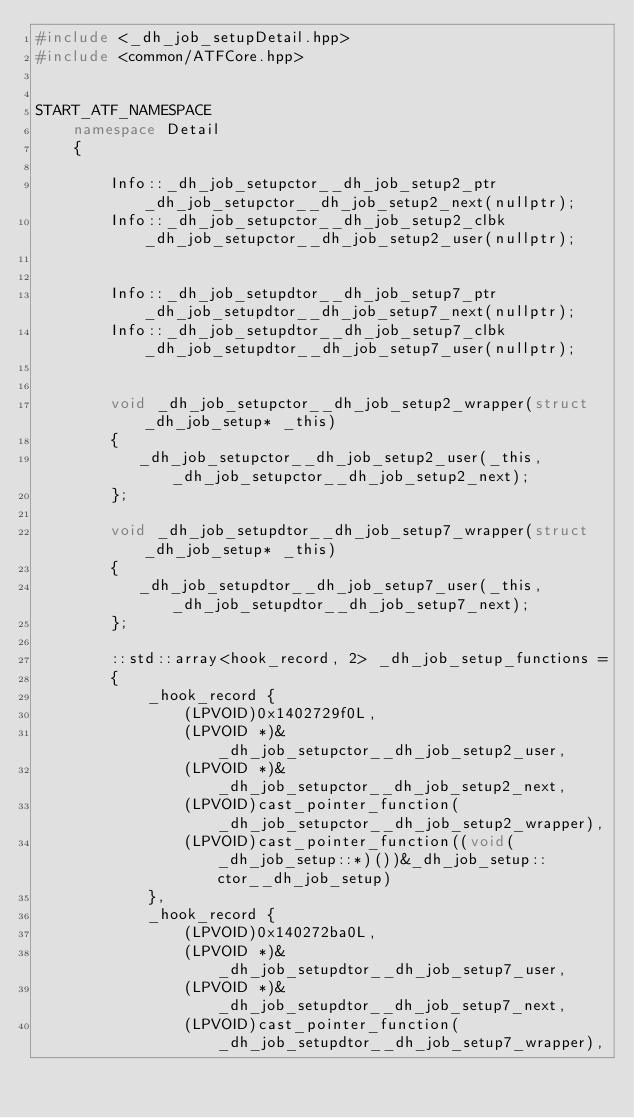Convert code to text. <code><loc_0><loc_0><loc_500><loc_500><_C++_>#include <_dh_job_setupDetail.hpp>
#include <common/ATFCore.hpp>


START_ATF_NAMESPACE
    namespace Detail
    {
        
        Info::_dh_job_setupctor__dh_job_setup2_ptr _dh_job_setupctor__dh_job_setup2_next(nullptr);
        Info::_dh_job_setupctor__dh_job_setup2_clbk _dh_job_setupctor__dh_job_setup2_user(nullptr);
        
        
        Info::_dh_job_setupdtor__dh_job_setup7_ptr _dh_job_setupdtor__dh_job_setup7_next(nullptr);
        Info::_dh_job_setupdtor__dh_job_setup7_clbk _dh_job_setupdtor__dh_job_setup7_user(nullptr);
        
        
        void _dh_job_setupctor__dh_job_setup2_wrapper(struct _dh_job_setup* _this)
        {
           _dh_job_setupctor__dh_job_setup2_user(_this, _dh_job_setupctor__dh_job_setup2_next);
        };
        
        void _dh_job_setupdtor__dh_job_setup7_wrapper(struct _dh_job_setup* _this)
        {
           _dh_job_setupdtor__dh_job_setup7_user(_this, _dh_job_setupdtor__dh_job_setup7_next);
        };
        
        ::std::array<hook_record, 2> _dh_job_setup_functions = 
        {
            _hook_record {
                (LPVOID)0x1402729f0L,
                (LPVOID *)&_dh_job_setupctor__dh_job_setup2_user,
                (LPVOID *)&_dh_job_setupctor__dh_job_setup2_next,
                (LPVOID)cast_pointer_function(_dh_job_setupctor__dh_job_setup2_wrapper),
                (LPVOID)cast_pointer_function((void(_dh_job_setup::*)())&_dh_job_setup::ctor__dh_job_setup)
            },
            _hook_record {
                (LPVOID)0x140272ba0L,
                (LPVOID *)&_dh_job_setupdtor__dh_job_setup7_user,
                (LPVOID *)&_dh_job_setupdtor__dh_job_setup7_next,
                (LPVOID)cast_pointer_function(_dh_job_setupdtor__dh_job_setup7_wrapper),</code> 